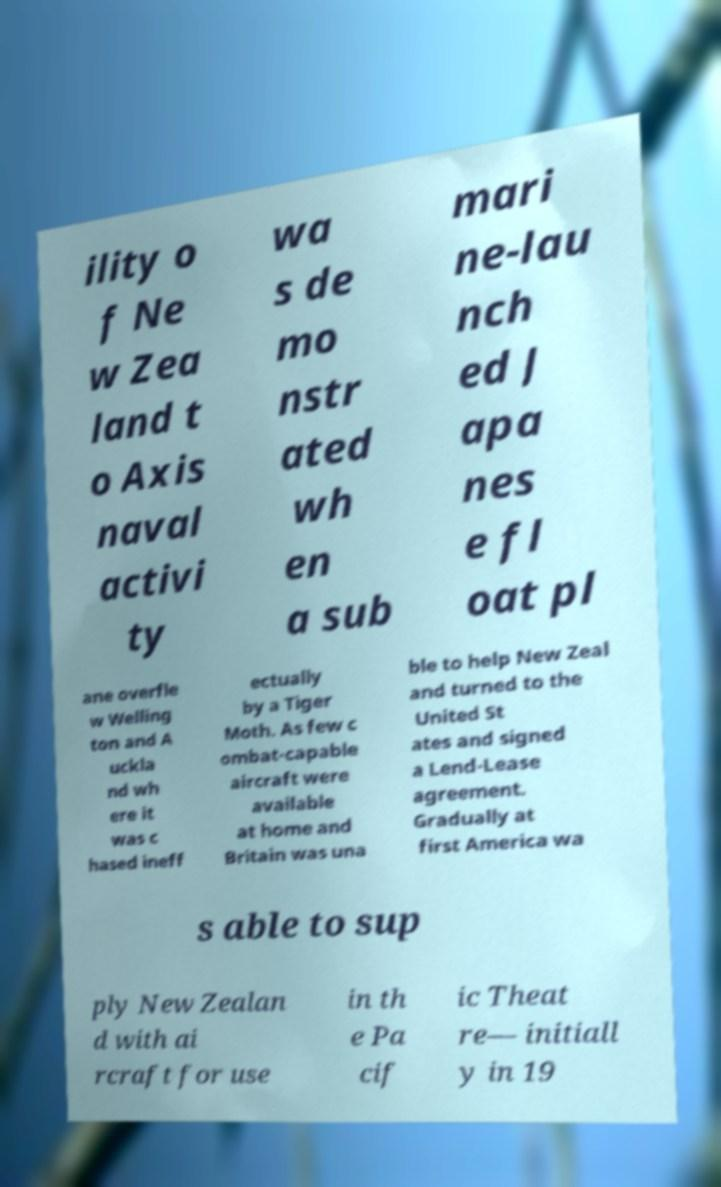Please identify and transcribe the text found in this image. ility o f Ne w Zea land t o Axis naval activi ty wa s de mo nstr ated wh en a sub mari ne-lau nch ed J apa nes e fl oat pl ane overfle w Welling ton and A uckla nd wh ere it was c hased ineff ectually by a Tiger Moth. As few c ombat-capable aircraft were available at home and Britain was una ble to help New Zeal and turned to the United St ates and signed a Lend-Lease agreement. Gradually at first America wa s able to sup ply New Zealan d with ai rcraft for use in th e Pa cif ic Theat re— initiall y in 19 